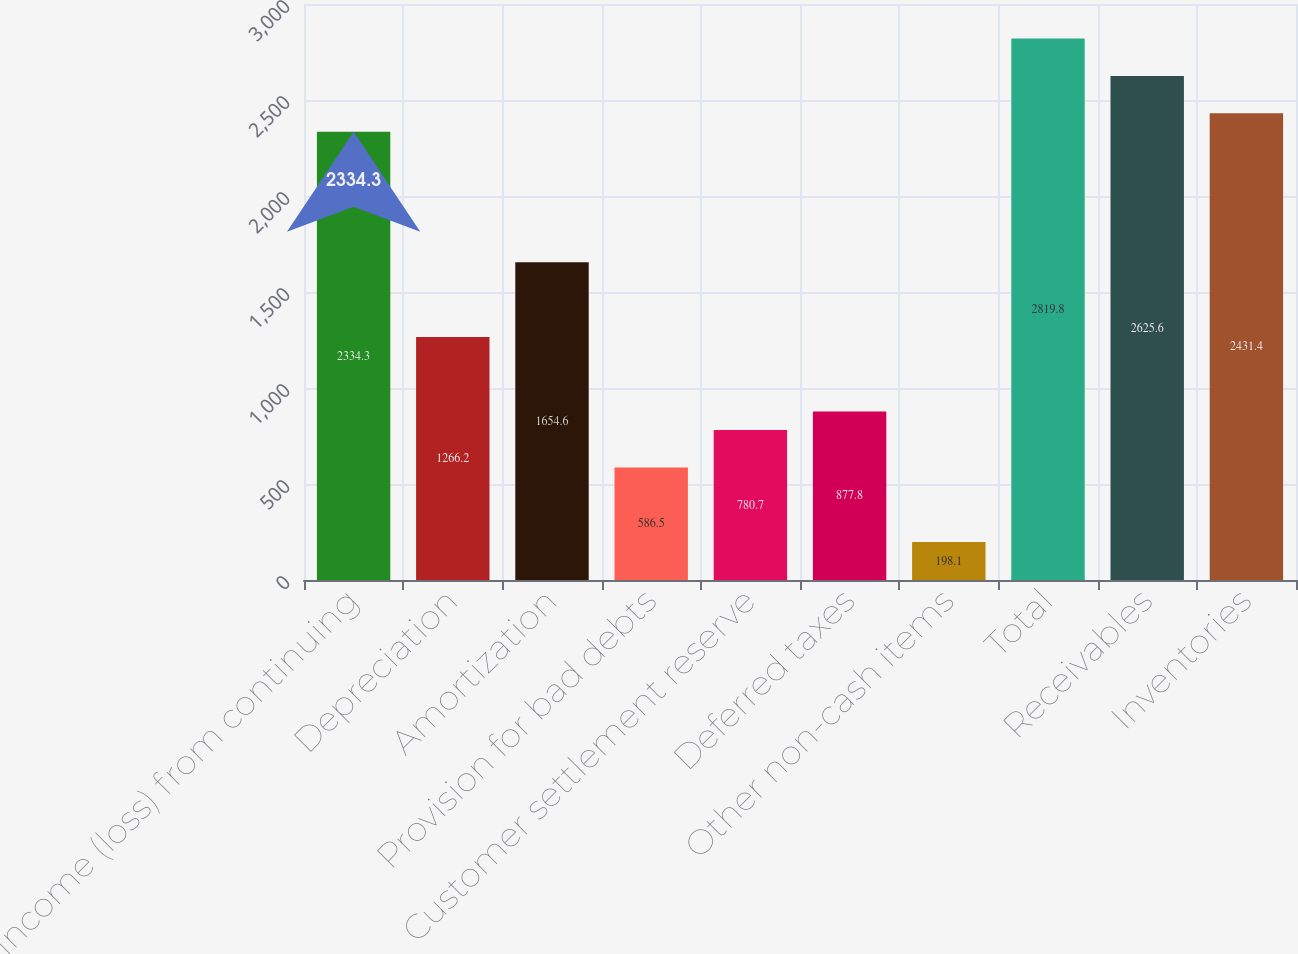Convert chart to OTSL. <chart><loc_0><loc_0><loc_500><loc_500><bar_chart><fcel>Income (loss) from continuing<fcel>Depreciation<fcel>Amortization<fcel>Provision for bad debts<fcel>Customer settlement reserve<fcel>Deferred taxes<fcel>Other non-cash items<fcel>Total<fcel>Receivables<fcel>Inventories<nl><fcel>2334.3<fcel>1266.2<fcel>1654.6<fcel>586.5<fcel>780.7<fcel>877.8<fcel>198.1<fcel>2819.8<fcel>2625.6<fcel>2431.4<nl></chart> 